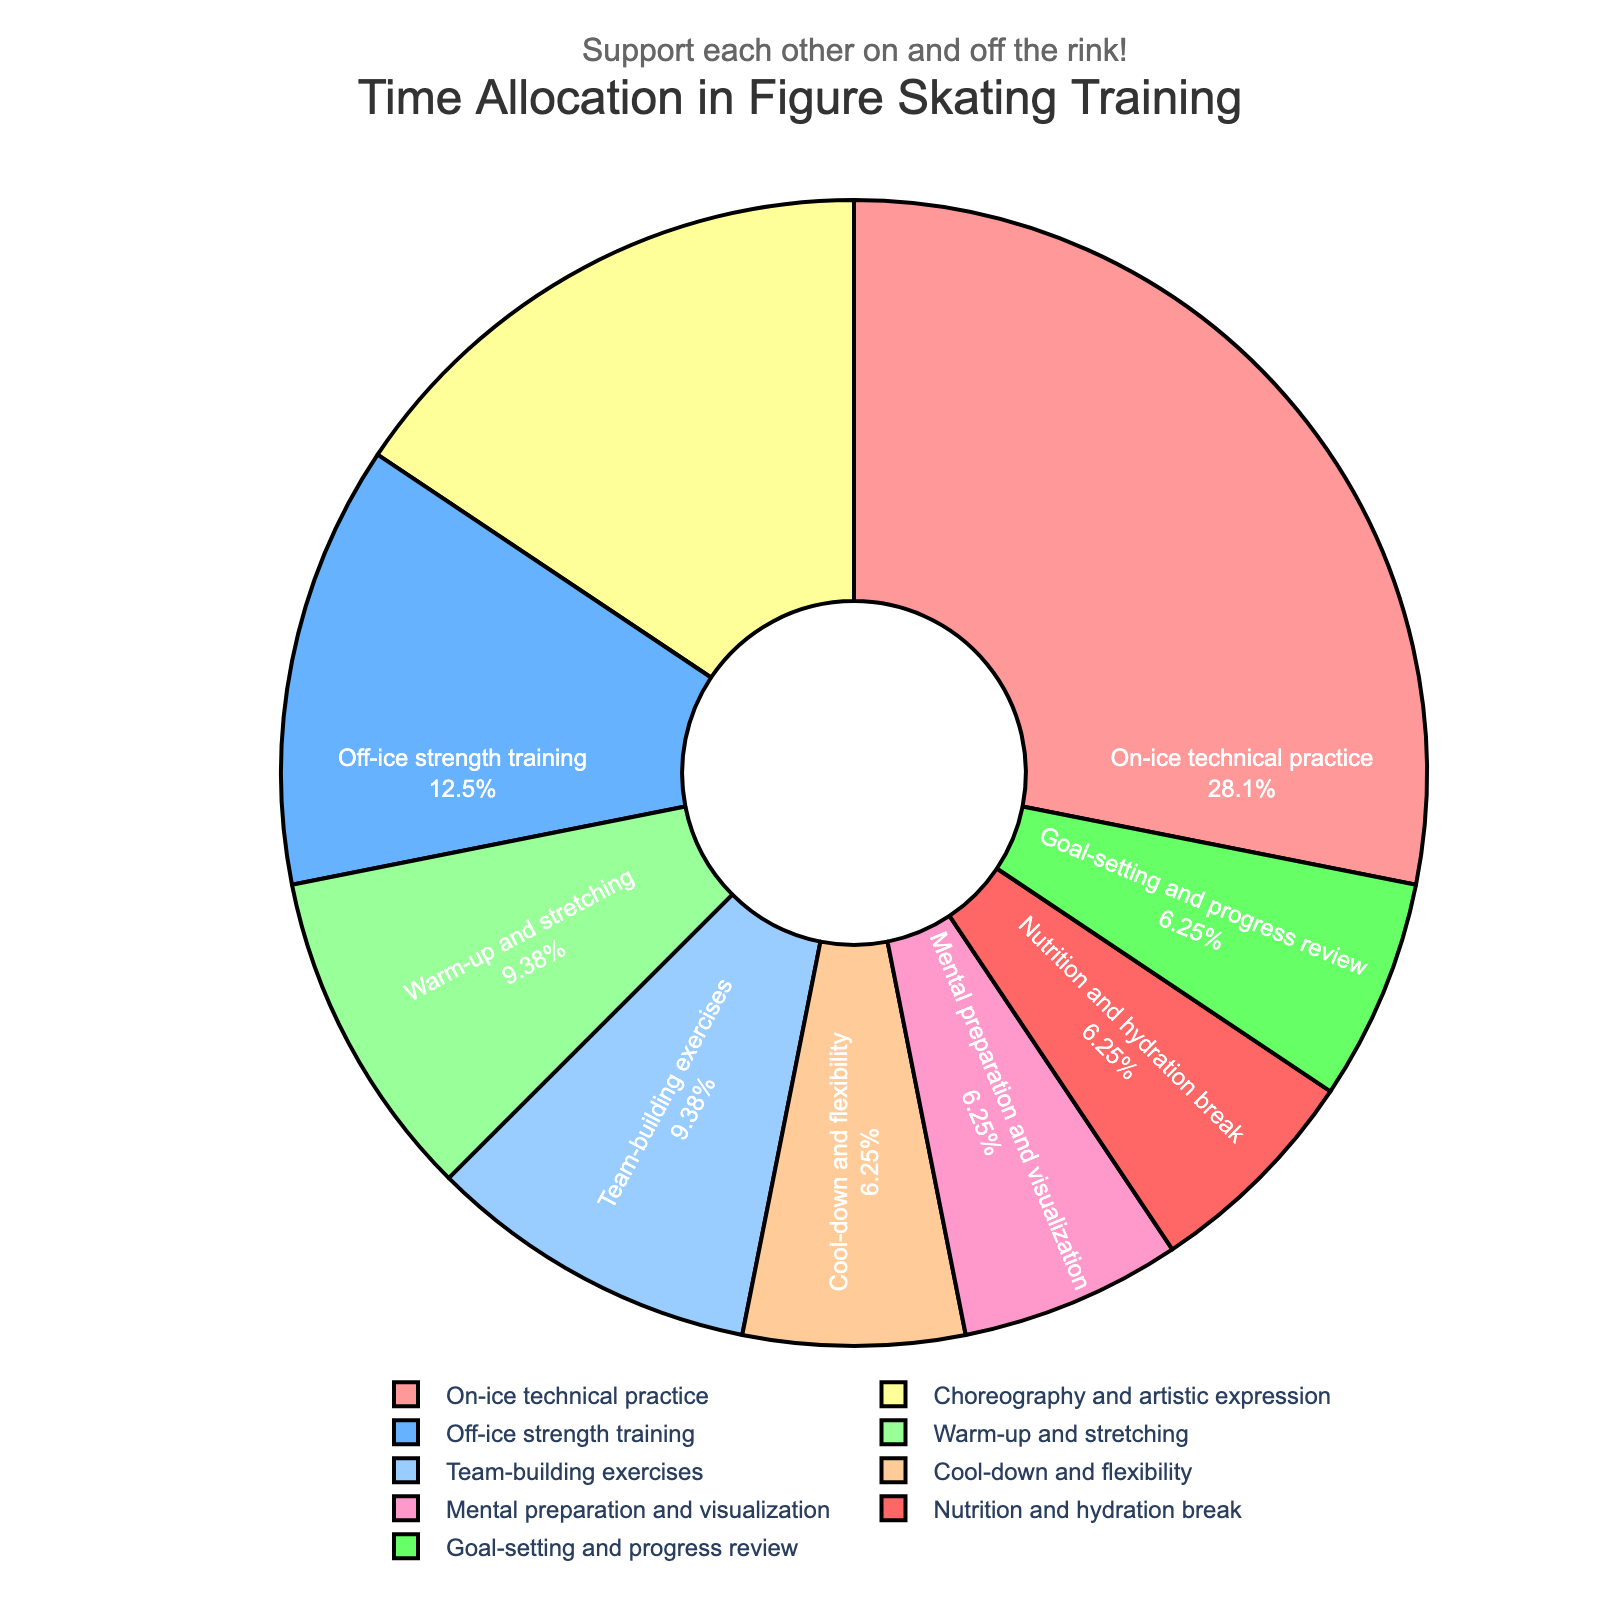What percentage of the training session is dedicated to on-ice technical practice? Look at the pie chart and locate the section labeled "On-ice technical practice". The percentage is displayed within the segment of the pie chart.
Answer: 30% Which component has more allocated time, choreography and artistic expression or team-building exercises? Compare the sizes of the segments labeled "Choreography and artistic expression" and "Team-building exercises". The first segment represents 16.7%, and the second represents 10%.
Answer: Choreography and artistic expression What's the total percentage of time spent on mental preparation and visualization, nutrition and hydration break, and goal-setting and progress review? Add the percentages of the segments labeled "Mental preparation and visualization" (6.7%), "Nutrition and hydration break" (6.7%), and "Goal-setting and progress review" (6.7%).
Answer: 20.1% Which activity has the smallest time allocation, and what is its percentage? Look for the smallest segment in the pie chart and check its label and the corresponding percentage.
Answer: Cool-down and flexibility, 6.7% What's the difference in allocated time between warm-up and stretching and off-ice strength training? Check the pie chart for the segments labeled "Warm-up and stretching" and "Off-ice strength training". Compute their difference by subtracting the percentage of "Warm-up and stretching" (10%) from "Off-ice strength training" (13.3%).
Answer: 3.3% Which component is allocated exactly 20% of the training session? Examine the pie chart for any segment with a label corresponding to 20%. However, based on our data, none of the segments have 20%.
Answer: None By how much is the time allocated for mental preparation and visualization greater than for cool-down and flexibility? Check the pie chart for the segments labeled "Mental preparation and visualization" (6.7%) and "Cool-down and flexibility" (6.7%), and subtract the second percentage from the first, which should indicate they are equal.
Answer: 0% Identify any two components with a combined allocated time of 30%. Look at the pie chart sections and find pairs of segments whose percentages add up to 30%. For example, "Warm-up and stretching" (10%) and "Off-ice strength training" (13.3%)
Answer: Warm-up and stretching and goal-setting and progress review What is the second largest component in the training session in terms of allocated time? Identify and compare the segments size-wise. "On-ice technical practice” is the largest (30%), followed by “Choreography and artistic expression” (16.7%).
Answer: Choreography and artistic expression How much more time is spent on on-ice technical practice than team-building exercises? From the pie chart, find the segments for "On-ice technical practice" and "Team-building exercises". Subtract the percentage of "Team-building exercises" (10%) from "On-ice technical practice" (30%).
Answer: 20% 